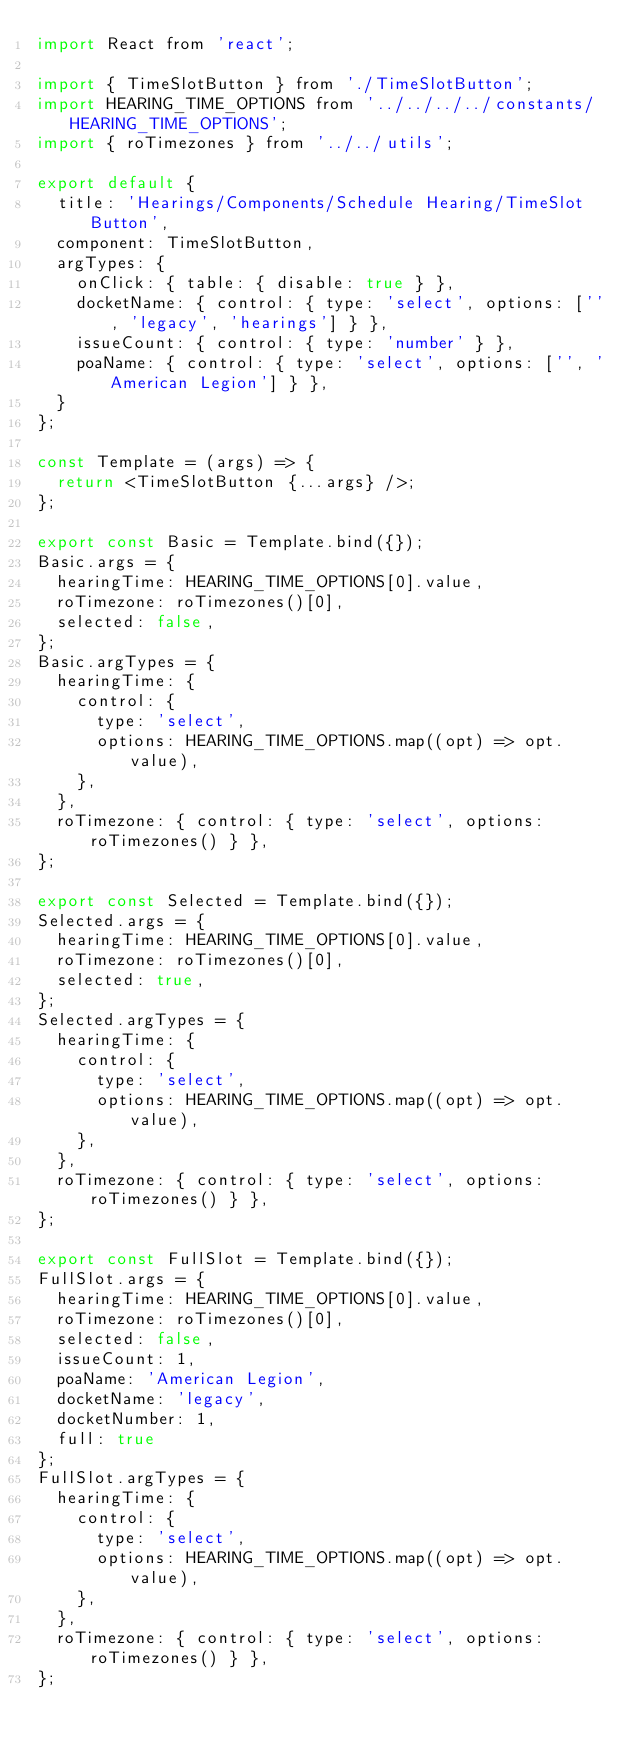Convert code to text. <code><loc_0><loc_0><loc_500><loc_500><_JavaScript_>import React from 'react';

import { TimeSlotButton } from './TimeSlotButton';
import HEARING_TIME_OPTIONS from '../../../../constants/HEARING_TIME_OPTIONS';
import { roTimezones } from '../../utils';

export default {
  title: 'Hearings/Components/Schedule Hearing/TimeSlot Button',
  component: TimeSlotButton,
  argTypes: {
    onClick: { table: { disable: true } },
    docketName: { control: { type: 'select', options: ['', 'legacy', 'hearings'] } },
    issueCount: { control: { type: 'number' } },
    poaName: { control: { type: 'select', options: ['', 'American Legion'] } },
  }
};

const Template = (args) => {
  return <TimeSlotButton {...args} />;
};

export const Basic = Template.bind({});
Basic.args = {
  hearingTime: HEARING_TIME_OPTIONS[0].value,
  roTimezone: roTimezones()[0],
  selected: false,
};
Basic.argTypes = {
  hearingTime: {
    control: {
      type: 'select',
      options: HEARING_TIME_OPTIONS.map((opt) => opt.value),
    },
  },
  roTimezone: { control: { type: 'select', options: roTimezones() } },
};

export const Selected = Template.bind({});
Selected.args = {
  hearingTime: HEARING_TIME_OPTIONS[0].value,
  roTimezone: roTimezones()[0],
  selected: true,
};
Selected.argTypes = {
  hearingTime: {
    control: {
      type: 'select',
      options: HEARING_TIME_OPTIONS.map((opt) => opt.value),
    },
  },
  roTimezone: { control: { type: 'select', options: roTimezones() } },
};

export const FullSlot = Template.bind({});
FullSlot.args = {
  hearingTime: HEARING_TIME_OPTIONS[0].value,
  roTimezone: roTimezones()[0],
  selected: false,
  issueCount: 1,
  poaName: 'American Legion',
  docketName: 'legacy',
  docketNumber: 1,
  full: true
};
FullSlot.argTypes = {
  hearingTime: {
    control: {
      type: 'select',
      options: HEARING_TIME_OPTIONS.map((opt) => opt.value),
    },
  },
  roTimezone: { control: { type: 'select', options: roTimezones() } },
};
</code> 